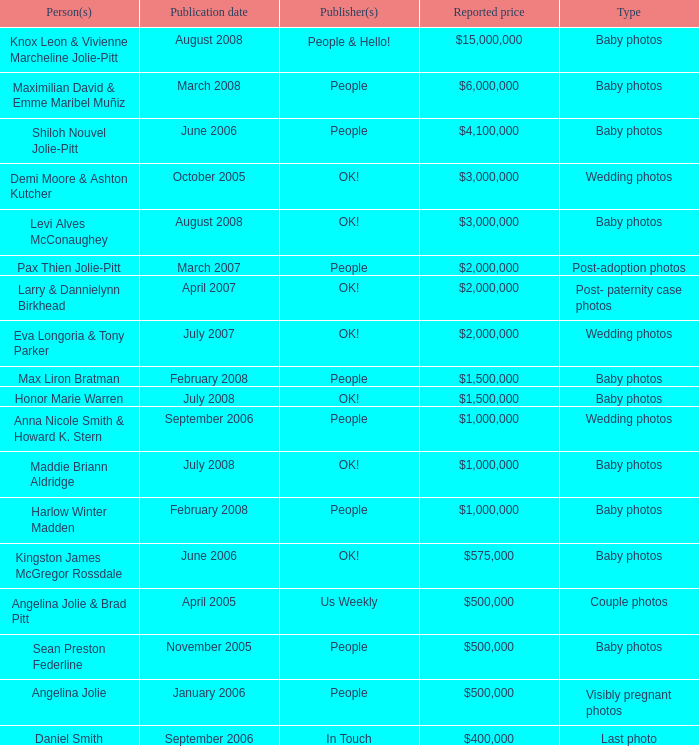What was the publication date of the photos of Sean Preston Federline that cost $500,000 and were published by People? November 2005. 